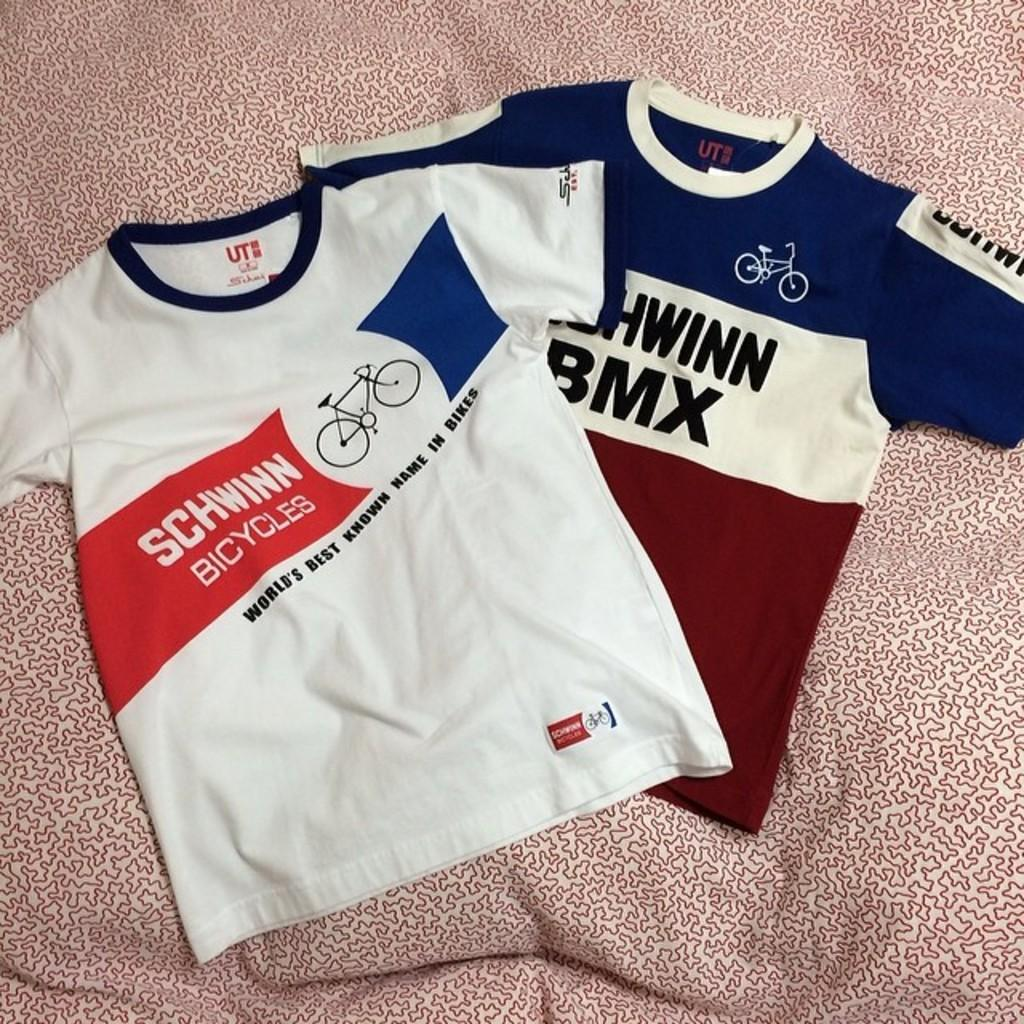<image>
Render a clear and concise summary of the photo. Schwinn Bicycles is the world's best known name in bikes. 